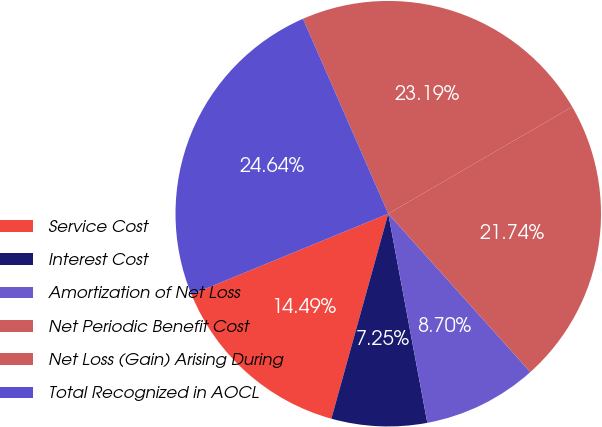Convert chart. <chart><loc_0><loc_0><loc_500><loc_500><pie_chart><fcel>Service Cost<fcel>Interest Cost<fcel>Amortization of Net Loss<fcel>Net Periodic Benefit Cost<fcel>Net Loss (Gain) Arising During<fcel>Total Recognized in AOCL<nl><fcel>14.49%<fcel>7.25%<fcel>8.7%<fcel>21.74%<fcel>23.19%<fcel>24.64%<nl></chart> 